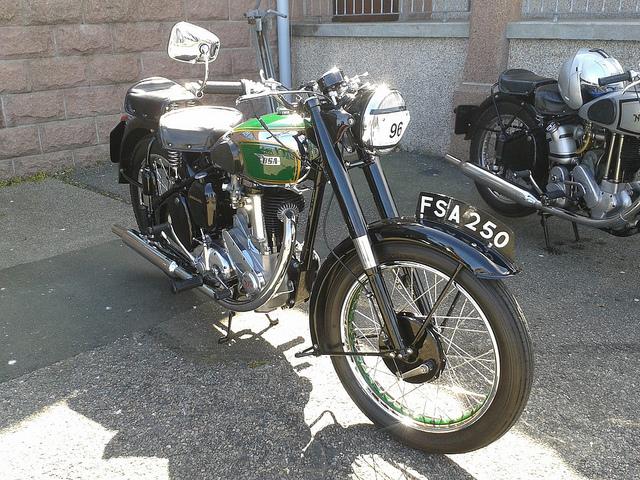Would this bike be strong enough for a full grown elephant to ride on?
Quick response, please. No. What do the number on the front tire mean?
Short answer required. License. What are the letters on the license plate?
Keep it brief. Fsa. Where is the 96?
Be succinct. Headlight. Would a motorcycle like this drive fast?
Concise answer only. Yes. What is the combination of letters and numbers on the tags of the motorcycles?
Give a very brief answer. Fsa250. 